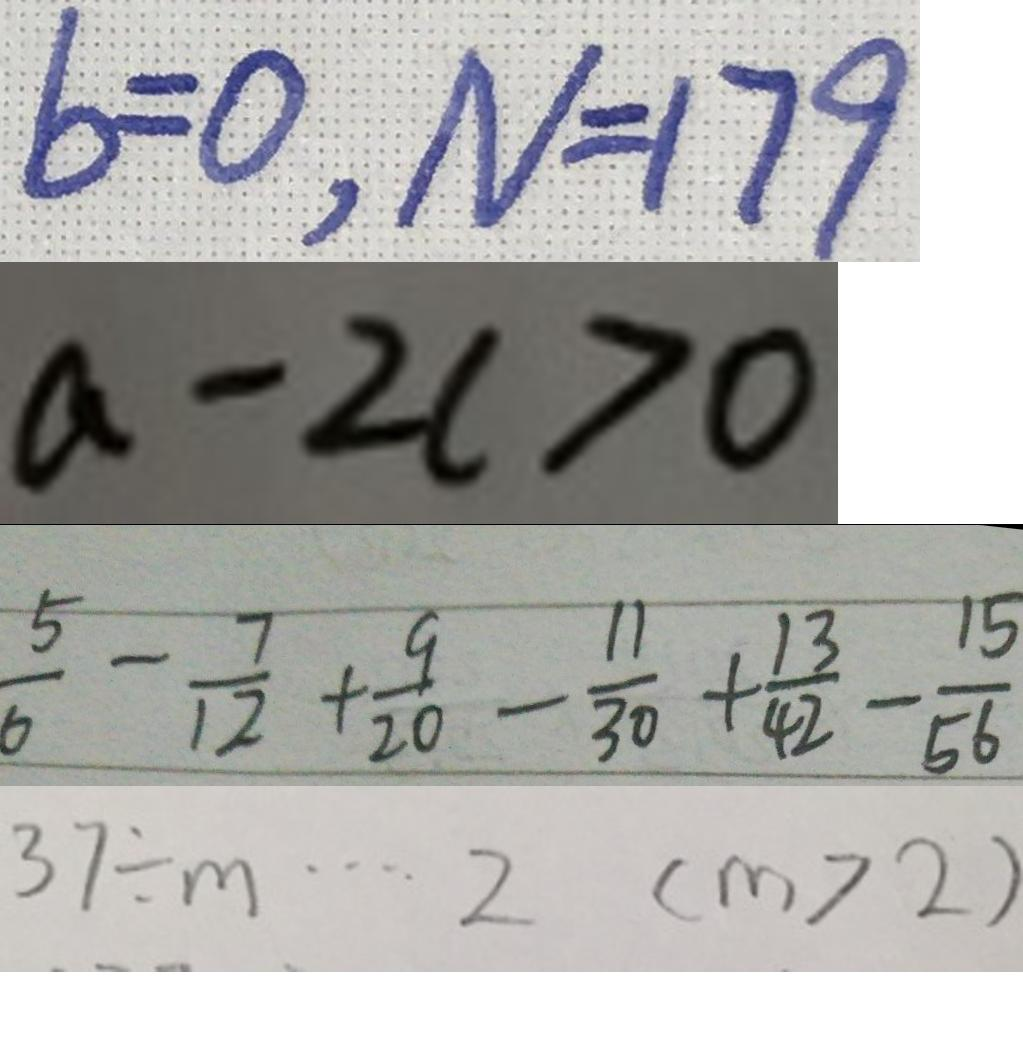Convert formula to latex. <formula><loc_0><loc_0><loc_500><loc_500>b = 0 , N = 1 7 9 
 a - 2 c > 0 
 \frac { 5 } { 6 } - \frac { 7 } { 1 2 } + \frac { 9 } { 2 0 } - \frac { 1 1 } { 3 0 } + \frac { 1 3 } { 4 2 } - \frac { 1 5 } { 5 6 } 
 3 7 \div m \cdots 2 ( m > 2 )</formula> 